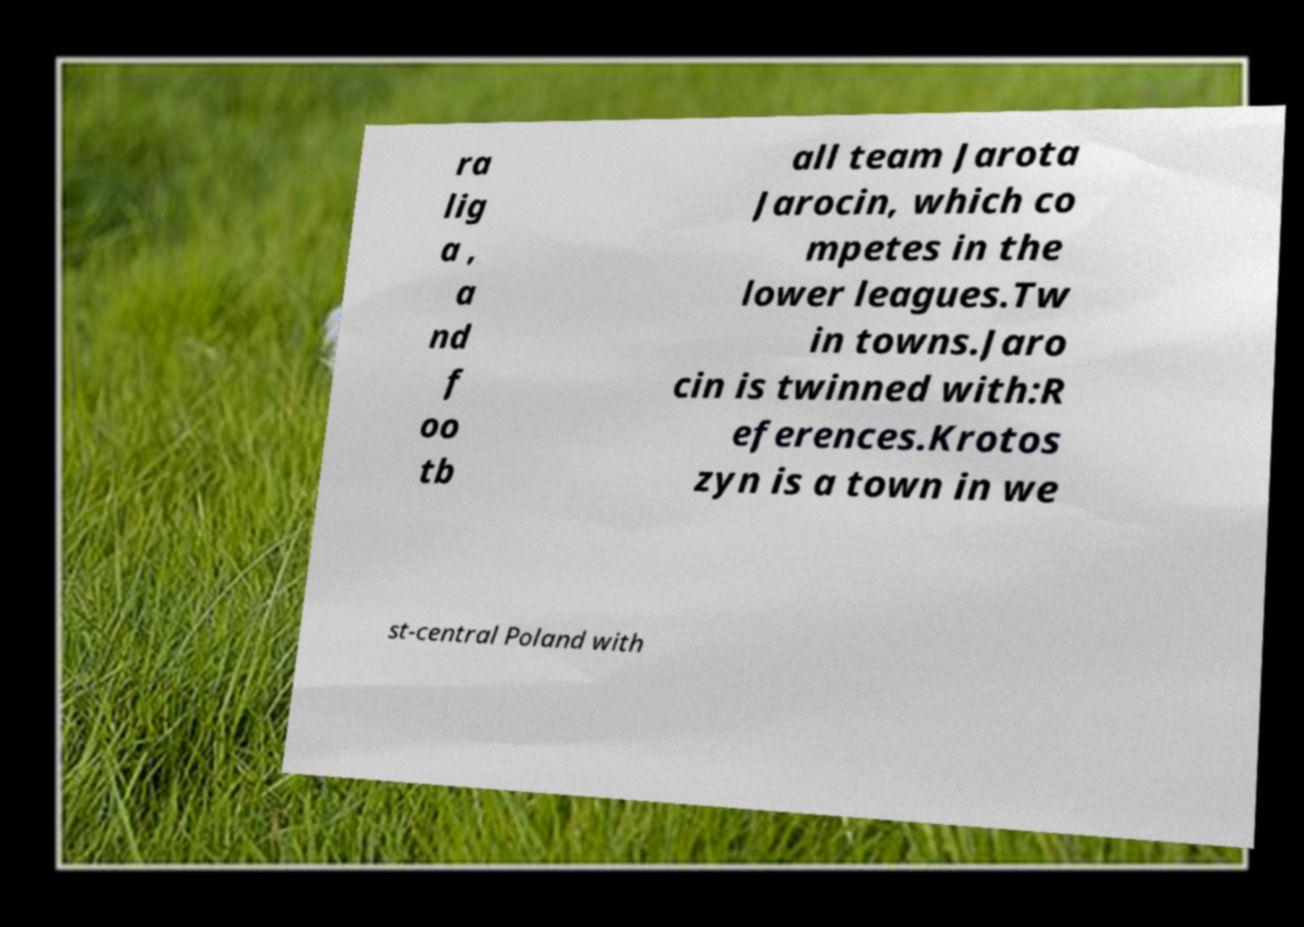Could you extract and type out the text from this image? ra lig a , a nd f oo tb all team Jarota Jarocin, which co mpetes in the lower leagues.Tw in towns.Jaro cin is twinned with:R eferences.Krotos zyn is a town in we st-central Poland with 